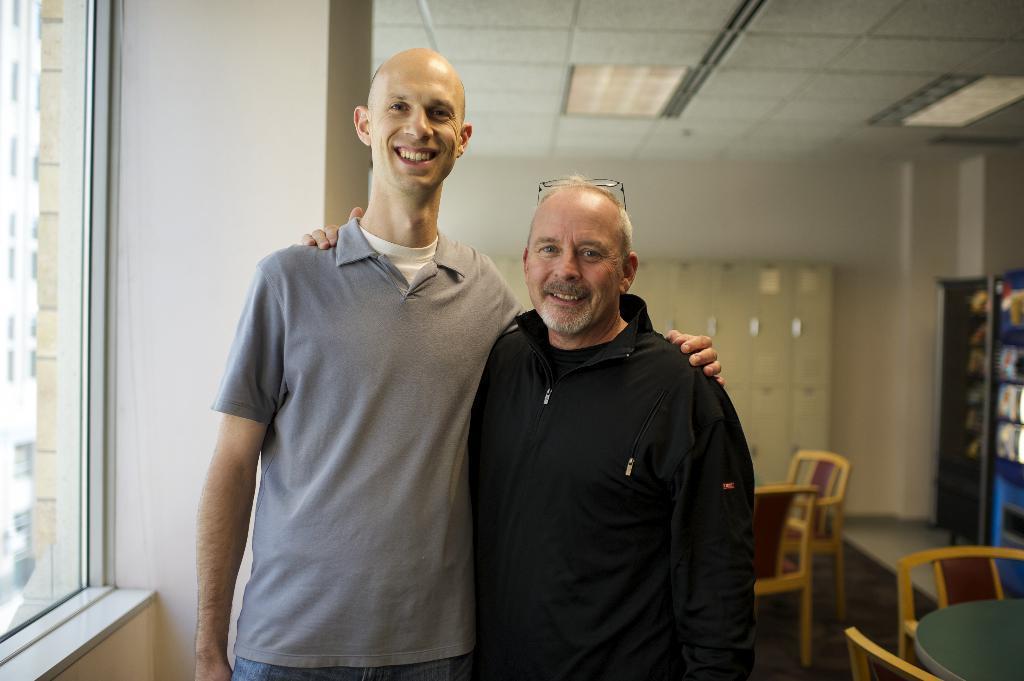Could you give a brief overview of what you see in this image? In this image there are two persons who are standing and smiling, on the top there is ceiling on the left side there is a window and wall. And on the background there are some tables and chairs. 